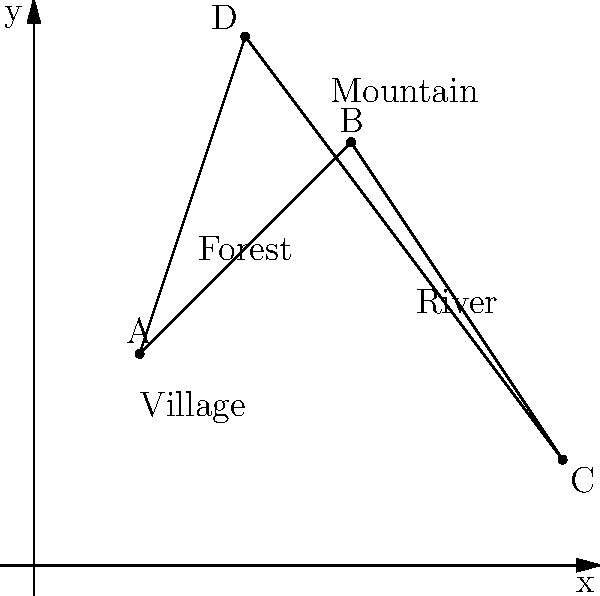In a children's story, four key locations are mapped on a 2D grid: the Village (A) at (1,2), the Forest (B) at (3,4), the Mountain (C) at (5,1), and the River (D) at (2,5). The protagonist needs to travel from the Village to the Mountain, passing through the Forest and the River in that order. Calculate the total distance traveled by the protagonist, rounded to two decimal places. To solve this problem, we need to calculate the distances between each pair of consecutive points and sum them up. We'll use the distance formula between two points: $d = \sqrt{(x_2-x_1)^2 + (y_2-y_1)^2}$

1. Distance from Village (A) to Forest (B):
   $d_{AB} = \sqrt{(3-1)^2 + (4-2)^2} = \sqrt{4 + 4} = \sqrt{8} \approx 2.83$

2. Distance from Forest (B) to River (D):
   $d_{BD} = \sqrt{(2-3)^2 + (5-4)^2} = \sqrt{1 + 1} = \sqrt{2} \approx 1.41$

3. Distance from River (D) to Mountain (C):
   $d_{DC} = \sqrt{(5-2)^2 + (1-5)^2} = \sqrt{9 + 16} = \sqrt{25} = 5$

4. Total distance:
   $d_{total} = d_{AB} + d_{BD} + d_{DC} \approx 2.83 + 1.41 + 5 = 9.24$

Rounding to two decimal places, we get 9.24 units.
Answer: 9.24 units 